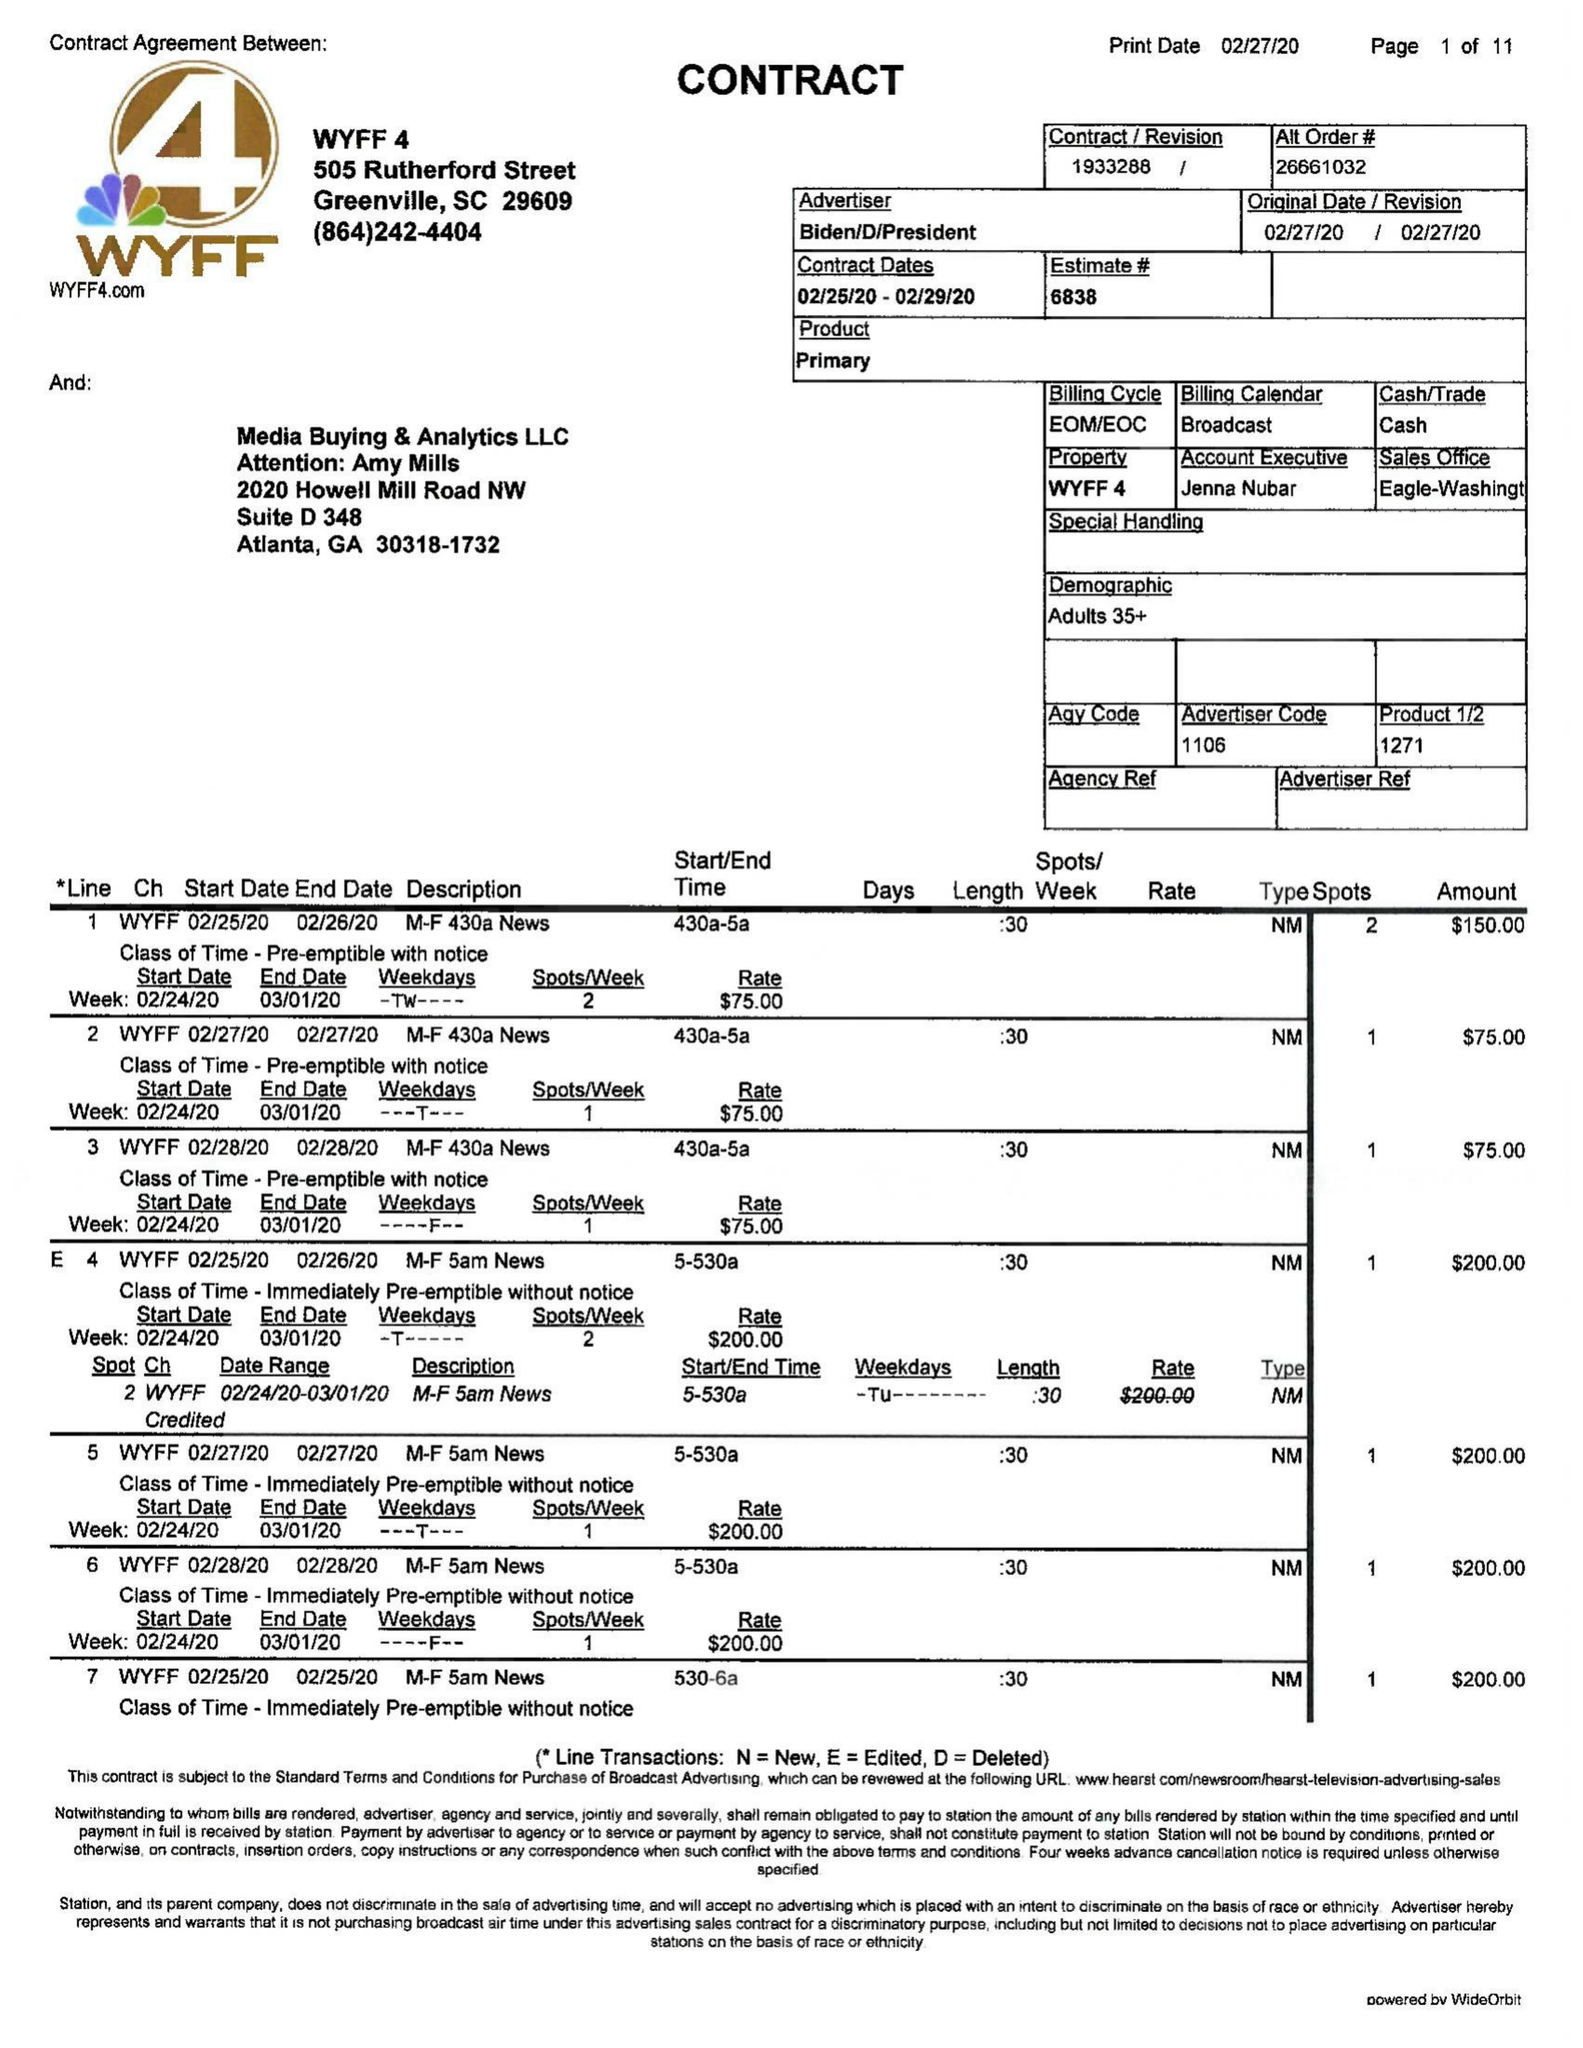What is the value for the flight_to?
Answer the question using a single word or phrase. 03/01/20 